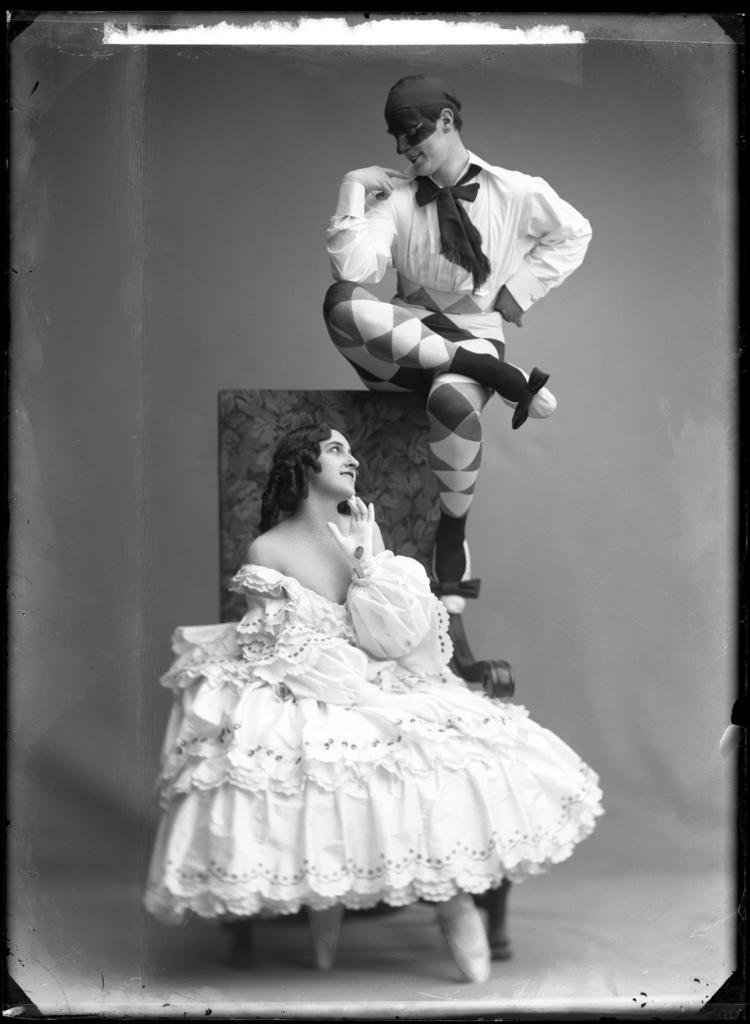What is the main subject of the image? The image contains an art piece. Can you describe the woman in the image? There is a woman sitting on a chair in the image, and she is wearing a white gown. What is the position of the person in relation to the woman? There is a person sitting above the chair in the image. What type of balloon is being used as a design element in the art piece? There is no balloon present in the image, and therefore no such design element can be observed. 